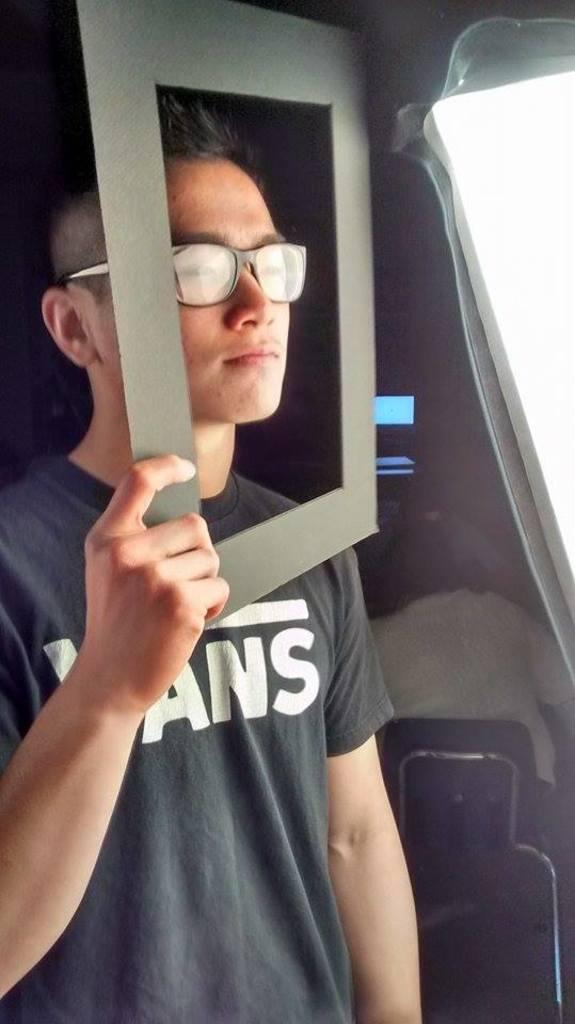What is the man in the front of the image doing? The man is standing in the front of the image and holding a board. Can you describe the board the man is holding? The board is black in color. What is happening in the background of the image? There is a person sitting in the background of the image. What type of turkey is being served on the table in the image? There is no table or turkey present in the image; it features a man holding a black board and a person sitting in the background. What territory is being claimed by the man in the image? There is no indication of territory being claimed in the image; the man is simply holding a black board. 